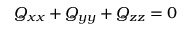Convert formula to latex. <formula><loc_0><loc_0><loc_500><loc_500>Q _ { x x } + Q _ { y y } + Q _ { z z } = 0</formula> 